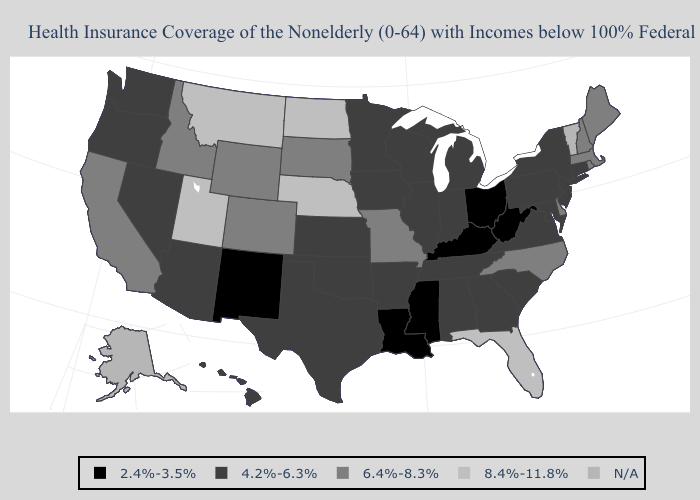What is the value of New York?
Answer briefly. 4.2%-6.3%. Does Michigan have the lowest value in the USA?
Keep it brief. No. What is the highest value in states that border Oregon?
Short answer required. 6.4%-8.3%. Name the states that have a value in the range 8.4%-11.8%?
Answer briefly. Florida, Montana, Nebraska, North Dakota, Utah. Does the first symbol in the legend represent the smallest category?
Quick response, please. Yes. What is the value of Kansas?
Quick response, please. 4.2%-6.3%. What is the highest value in states that border Illinois?
Keep it brief. 6.4%-8.3%. Does Kansas have the lowest value in the MidWest?
Keep it brief. No. Does Ohio have the lowest value in the USA?
Be succinct. Yes. Does Louisiana have the lowest value in the USA?
Answer briefly. Yes. What is the value of New Jersey?
Concise answer only. 4.2%-6.3%. What is the highest value in states that border Kansas?
Write a very short answer. 8.4%-11.8%. What is the value of Utah?
Write a very short answer. 8.4%-11.8%. What is the lowest value in the MidWest?
Write a very short answer. 2.4%-3.5%. What is the highest value in states that border Maine?
Short answer required. 6.4%-8.3%. 